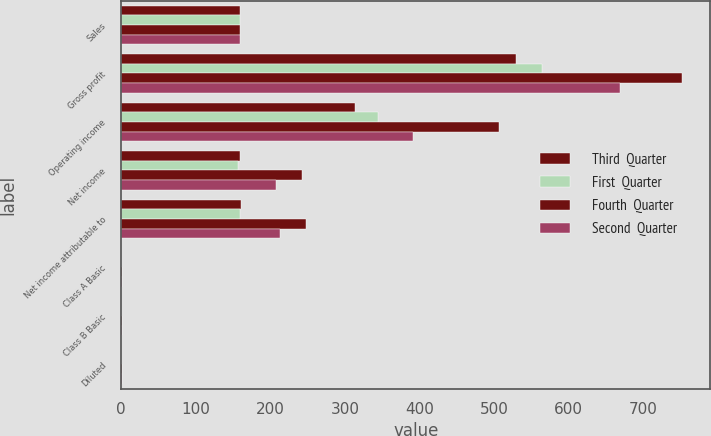<chart> <loc_0><loc_0><loc_500><loc_500><stacked_bar_chart><ecel><fcel>Sales<fcel>Gross profit<fcel>Operating income<fcel>Net income<fcel>Net income attributable to<fcel>Class A Basic<fcel>Class B Basic<fcel>Diluted<nl><fcel>Third  Quarter<fcel>159<fcel>529<fcel>314<fcel>159<fcel>160<fcel>0.44<fcel>0.39<fcel>0.42<nl><fcel>First  Quarter<fcel>159<fcel>564<fcel>344<fcel>156<fcel>159<fcel>0.43<fcel>0.39<fcel>0.42<nl><fcel>Fourth  Quarter<fcel>159<fcel>752<fcel>507<fcel>242<fcel>248<fcel>0.68<fcel>0.61<fcel>0.65<nl><fcel>Second  Quarter<fcel>159<fcel>669<fcel>391<fcel>208<fcel>213<fcel>0.58<fcel>0.52<fcel>0.57<nl></chart> 